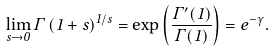<formula> <loc_0><loc_0><loc_500><loc_500>\lim _ { s \to 0 } \Gamma \left ( 1 + s \right ) ^ { 1 / s } = \exp \left ( \frac { \Gamma ^ { \prime } ( 1 ) } { \Gamma ( 1 ) } \right ) = e ^ { - \gamma } .</formula> 